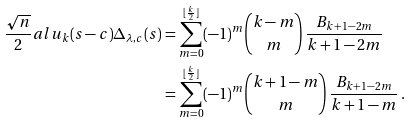<formula> <loc_0><loc_0><loc_500><loc_500>\frac { \sqrt { n } } { 2 } a l { u _ { k } ( s - c ) } { \Delta _ { \lambda , c } ( s ) } & = \sum _ { m = 0 } ^ { \lfloor \frac { k } { 2 } \rfloor } ( - 1 ) ^ { m } \binom { k - m } { m } \, \frac { B _ { k + 1 - 2 m } } { k + 1 - 2 m } \\ & = \sum _ { m = 0 } ^ { \lfloor \frac { k } { 2 } \rfloor } ( - 1 ) ^ { m } \binom { k + 1 - m } { m } \, \frac { B _ { k + 1 - 2 m } } { k + 1 - m } \, .</formula> 